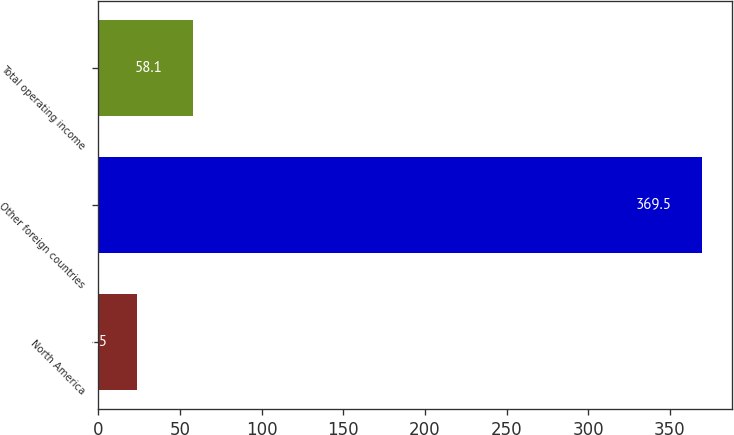Convert chart. <chart><loc_0><loc_0><loc_500><loc_500><bar_chart><fcel>North America<fcel>Other foreign countries<fcel>Total operating income<nl><fcel>23.5<fcel>369.5<fcel>58.1<nl></chart> 